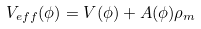<formula> <loc_0><loc_0><loc_500><loc_500>V _ { e f f } ( \phi ) = V ( \phi ) + A ( \phi ) \rho _ { m }</formula> 